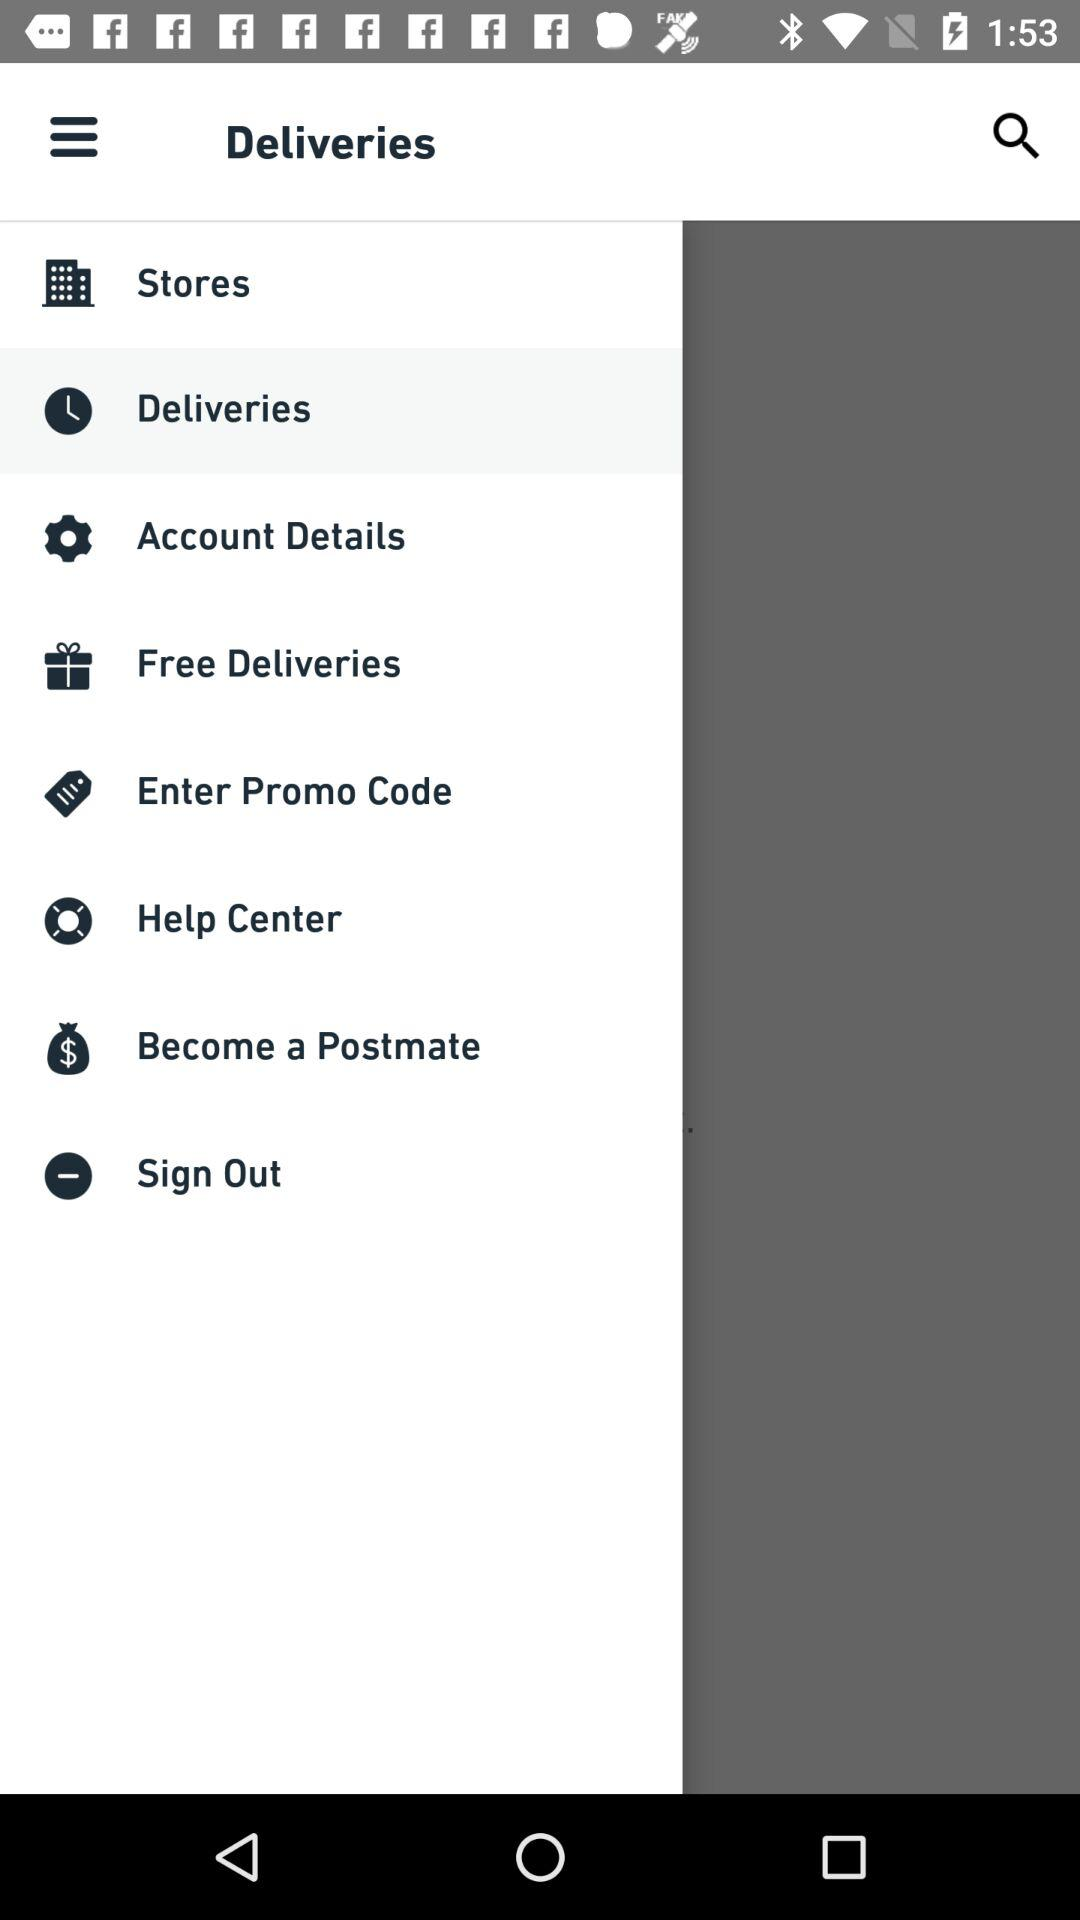What option has been selected? The selected option is "Deliveries". 